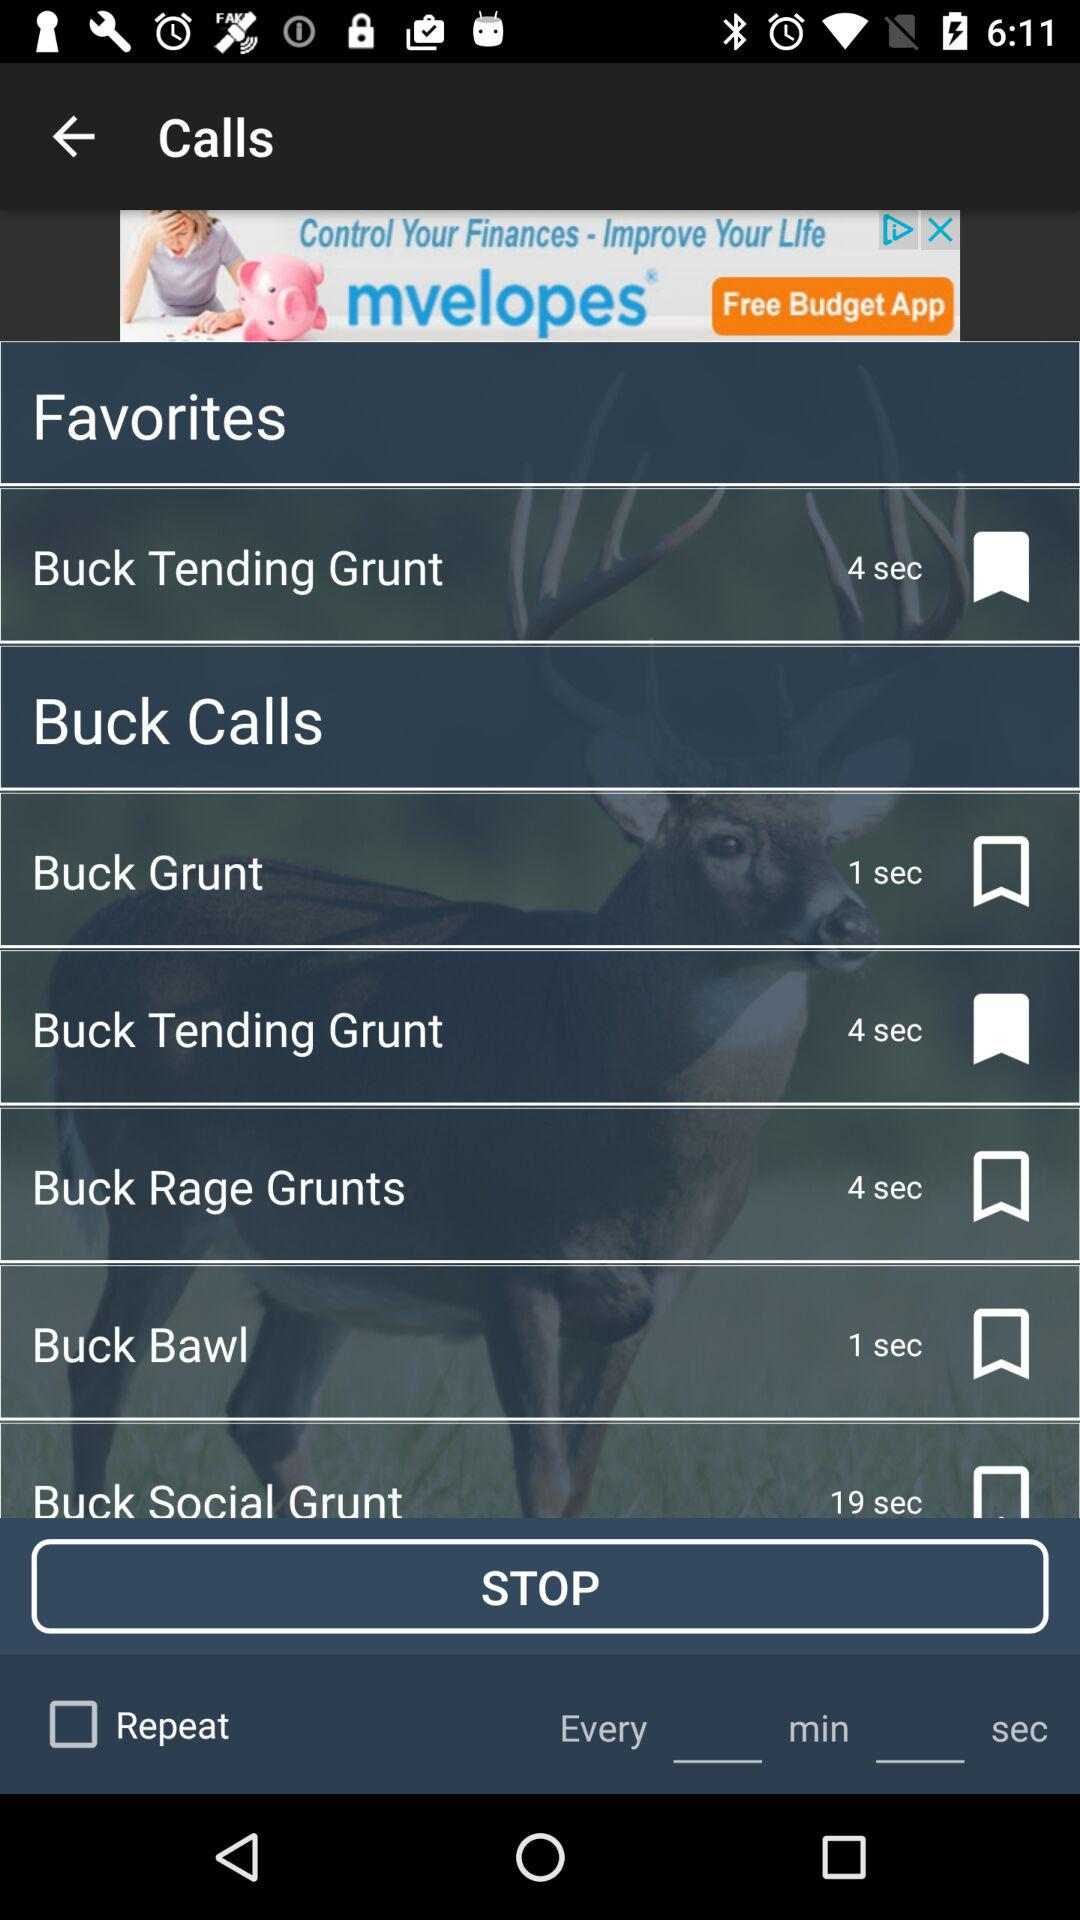How long is the "Buck Grunt" in seconds? It is one second long. 